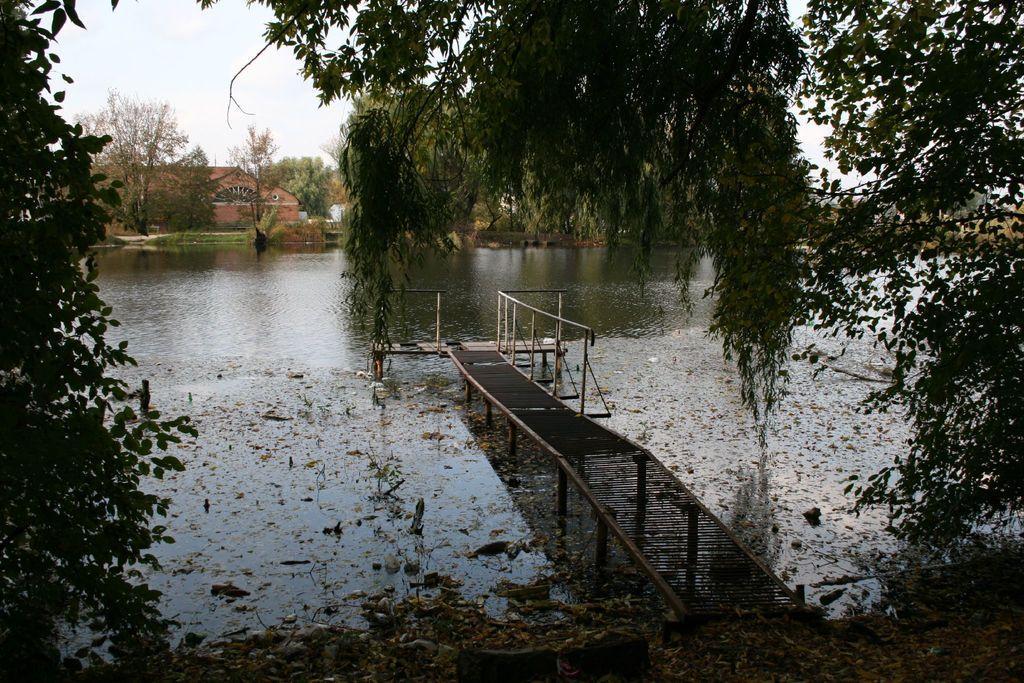Please provide a concise description of this image. In this image we can see a walkway bridge, shredded leaves, trees, lake, buildings and sky. 